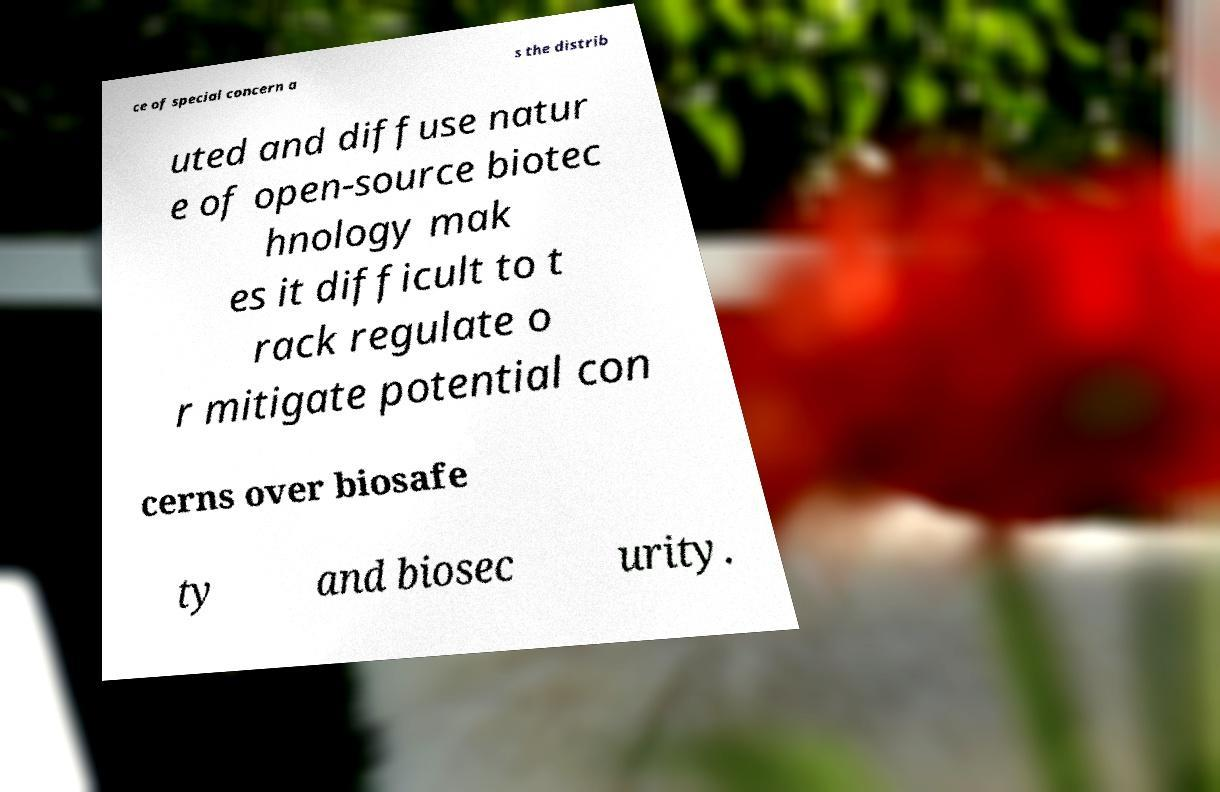Could you extract and type out the text from this image? ce of special concern a s the distrib uted and diffuse natur e of open-source biotec hnology mak es it difficult to t rack regulate o r mitigate potential con cerns over biosafe ty and biosec urity. 